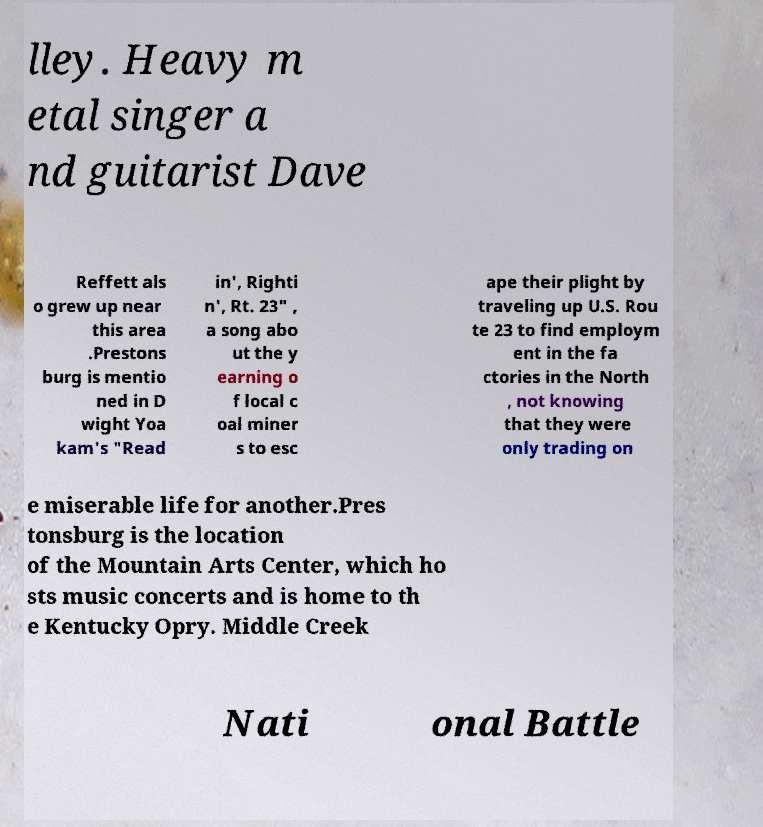Please identify and transcribe the text found in this image. lley. Heavy m etal singer a nd guitarist Dave Reffett als o grew up near this area .Prestons burg is mentio ned in D wight Yoa kam's "Read in', Righti n', Rt. 23" , a song abo ut the y earning o f local c oal miner s to esc ape their plight by traveling up U.S. Rou te 23 to find employm ent in the fa ctories in the North , not knowing that they were only trading on e miserable life for another.Pres tonsburg is the location of the Mountain Arts Center, which ho sts music concerts and is home to th e Kentucky Opry. Middle Creek Nati onal Battle 